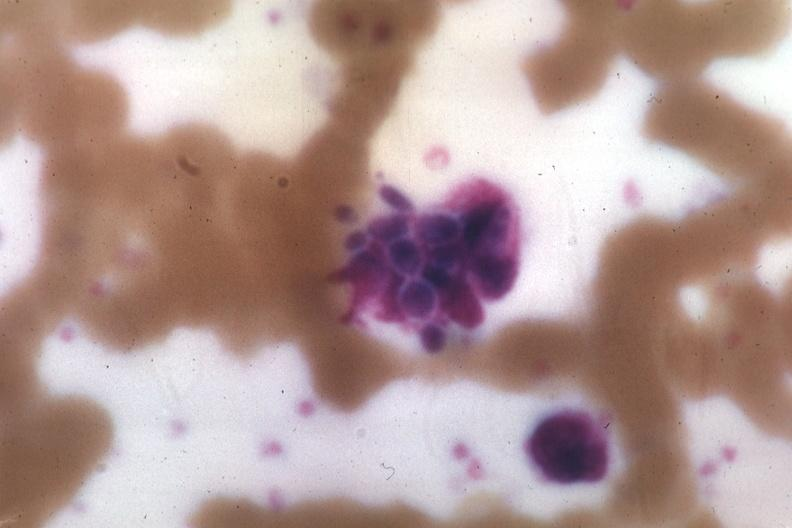does normal immature infant show wrights yeast forms?
Answer the question using a single word or phrase. No 